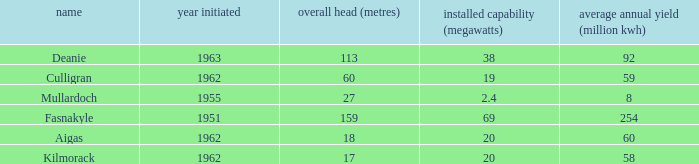What is the Year commissioned of the power station with a Gross head of 60 metres and Average annual output of less than 59 million KWh? None. 